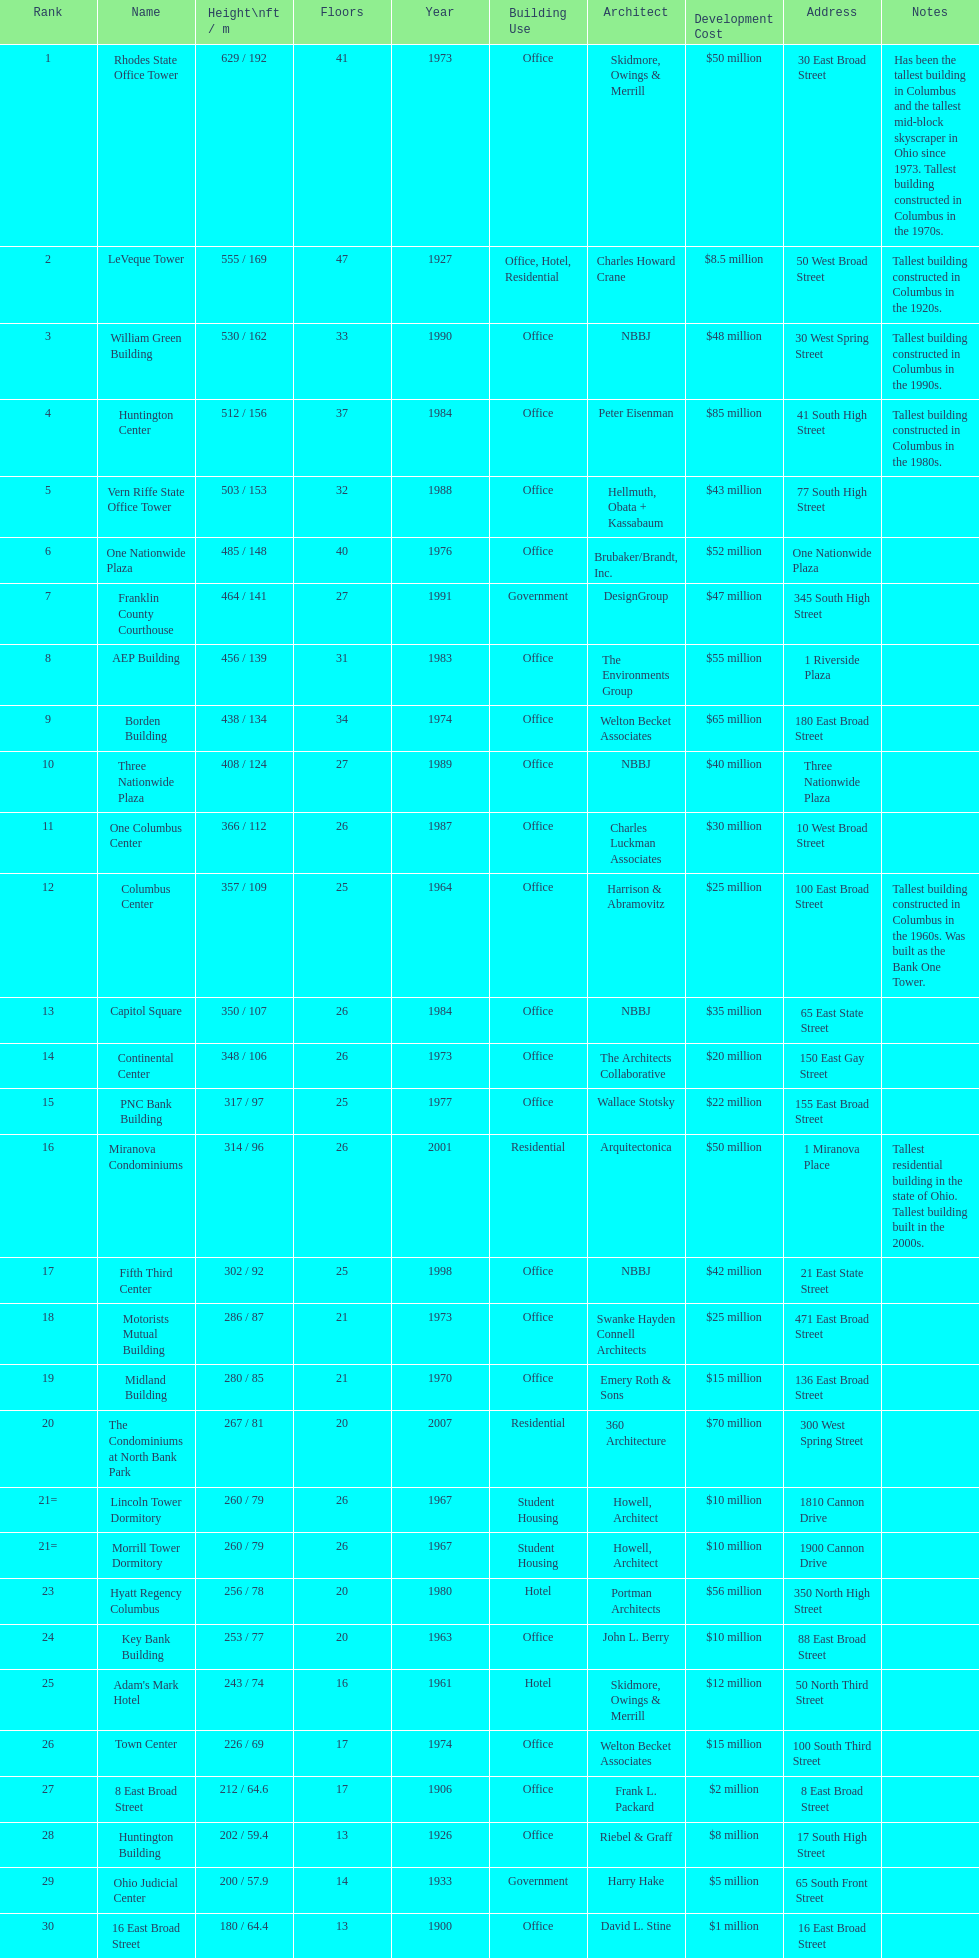Which is taller, the aep building or the one columbus center? AEP Building. 